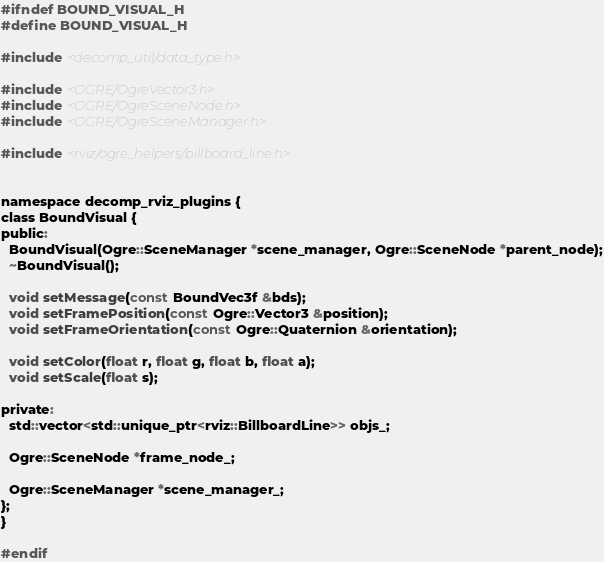Convert code to text. <code><loc_0><loc_0><loc_500><loc_500><_C_>#ifndef BOUND_VISUAL_H
#define BOUND_VISUAL_H

#include <decomp_util/data_type.h>

#include <OGRE/OgreVector3.h>
#include <OGRE/OgreSceneNode.h>
#include <OGRE/OgreSceneManager.h>

#include <rviz/ogre_helpers/billboard_line.h>


namespace decomp_rviz_plugins {
class BoundVisual {
public:
  BoundVisual(Ogre::SceneManager *scene_manager, Ogre::SceneNode *parent_node);
  ~BoundVisual();

  void setMessage(const BoundVec3f &bds);
  void setFramePosition(const Ogre::Vector3 &position);
  void setFrameOrientation(const Ogre::Quaternion &orientation);

  void setColor(float r, float g, float b, float a);
  void setScale(float s);

private:
  std::vector<std::unique_ptr<rviz::BillboardLine>> objs_;

  Ogre::SceneNode *frame_node_;

  Ogre::SceneManager *scene_manager_;
};
}

#endif
</code> 